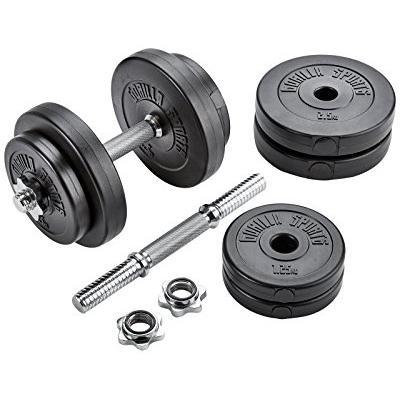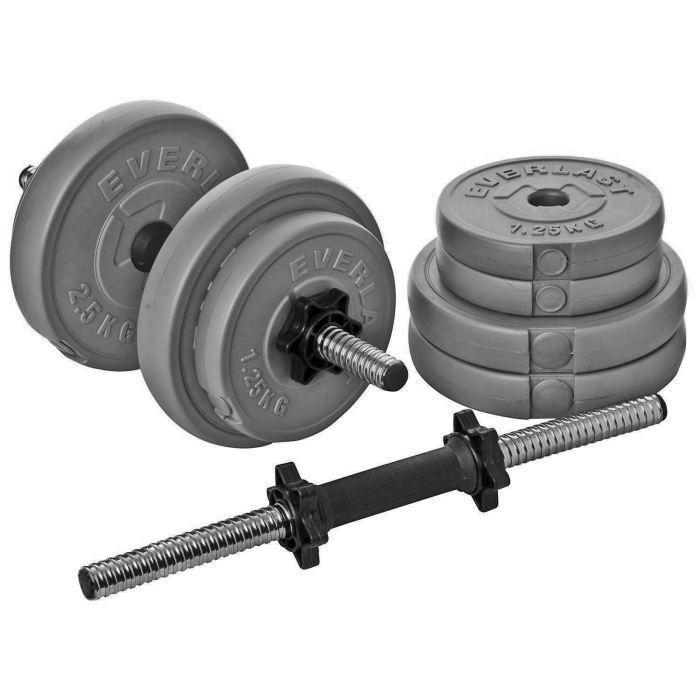The first image is the image on the left, the second image is the image on the right. Considering the images on both sides, is "There are exactly three dumbbells." valid? Answer yes or no. No. The first image is the image on the left, the second image is the image on the right. For the images displayed, is the sentence "The left image contains two dumbells without pipe sticking out." factually correct? Answer yes or no. No. 